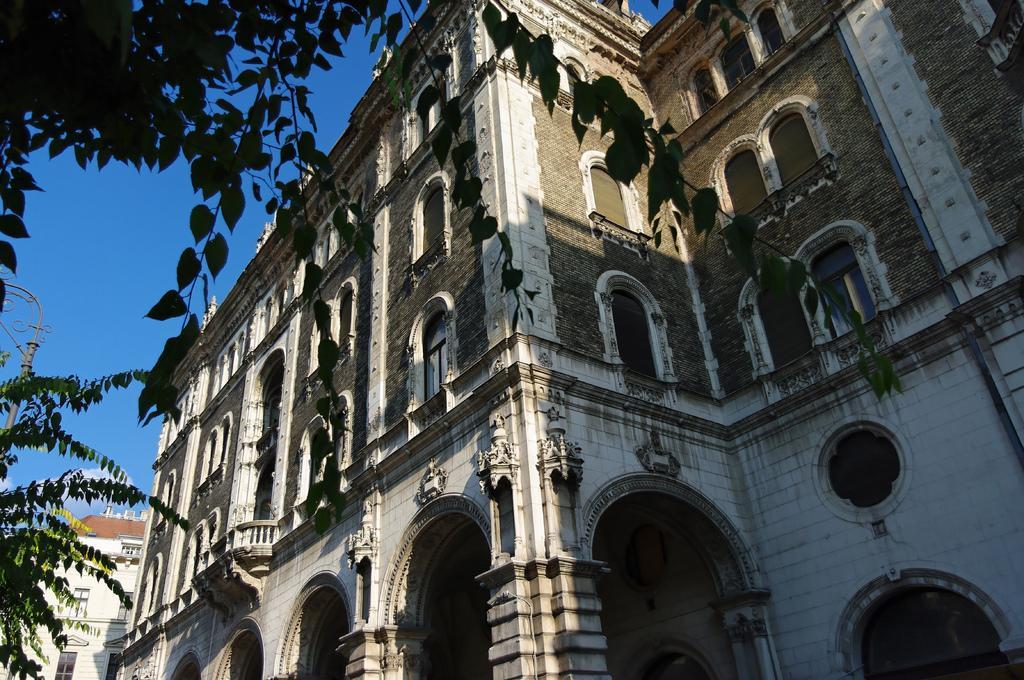Could you give a brief overview of what you see in this image? In this picture we can see buildings, on the left side there is a pole and a tree, we can see the sky in the background. 